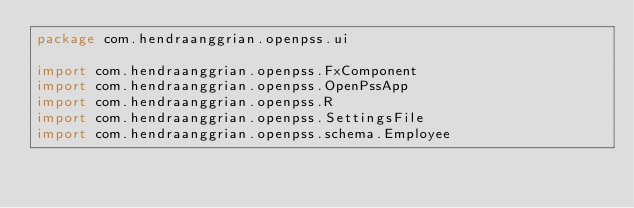<code> <loc_0><loc_0><loc_500><loc_500><_Kotlin_>package com.hendraanggrian.openpss.ui

import com.hendraanggrian.openpss.FxComponent
import com.hendraanggrian.openpss.OpenPssApp
import com.hendraanggrian.openpss.R
import com.hendraanggrian.openpss.SettingsFile
import com.hendraanggrian.openpss.schema.Employee</code> 